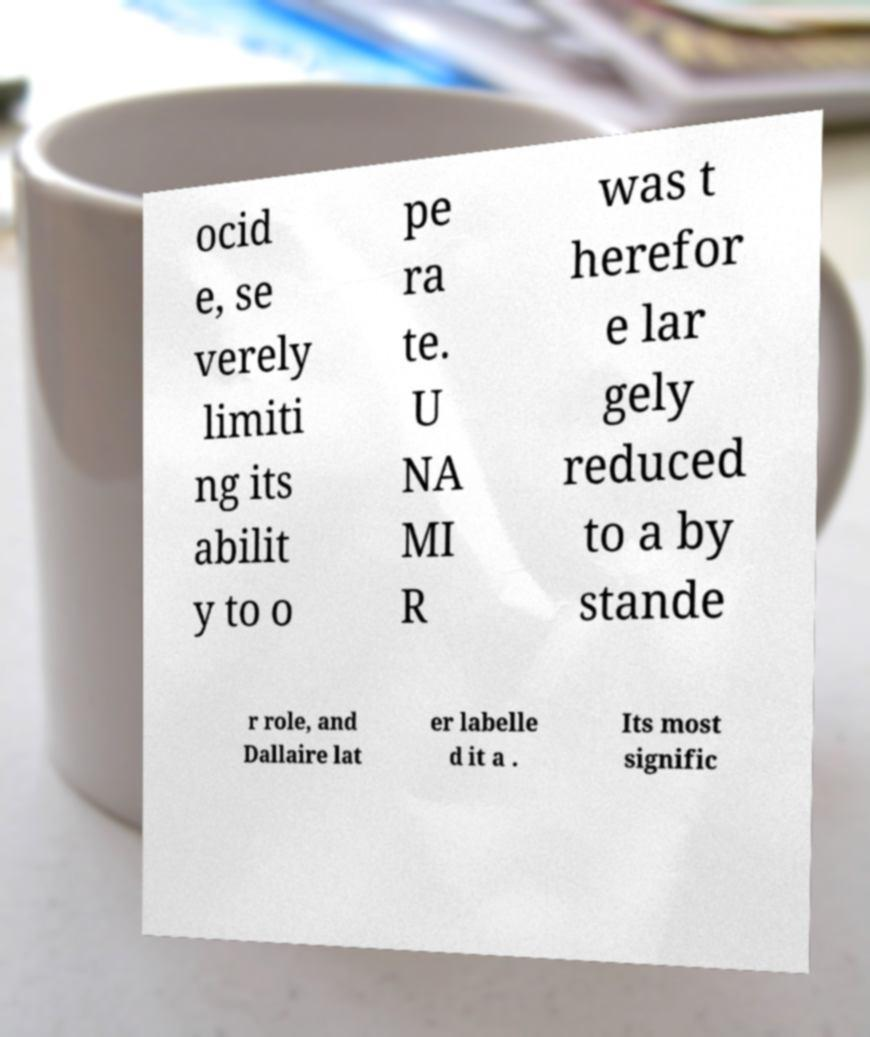Please identify and transcribe the text found in this image. ocid e, se verely limiti ng its abilit y to o pe ra te. U NA MI R was t herefor e lar gely reduced to a by stande r role, and Dallaire lat er labelle d it a . Its most signific 